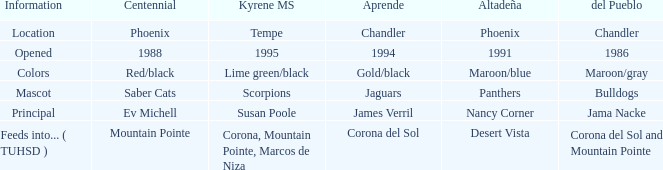Could you parse the entire table? {'header': ['Information', 'Centennial', 'Kyrene MS', 'Aprende', 'Altadeña', 'del Pueblo'], 'rows': [['Location', 'Phoenix', 'Tempe', 'Chandler', 'Phoenix', 'Chandler'], ['Opened', '1988', '1995', '1994', '1991', '1986'], ['Colors', 'Red/black', 'Lime green/black', 'Gold/black', 'Maroon/blue', 'Maroon/gray'], ['Mascot', 'Saber Cats', 'Scorpions', 'Jaguars', 'Panthers', 'Bulldogs'], ['Principal', 'Ev Michell', 'Susan Poole', 'James Verril', 'Nancy Corner', 'Jama Nacke'], ['Feeds into... ( TUHSD )', 'Mountain Pointe', 'Corona, Mountain Pointe, Marcos de Niza', 'Corona del Sol', 'Desert Vista', 'Corona del Sol and Mountain Pointe']]} Which Centennial has a Altadeña of panthers? Saber Cats. 